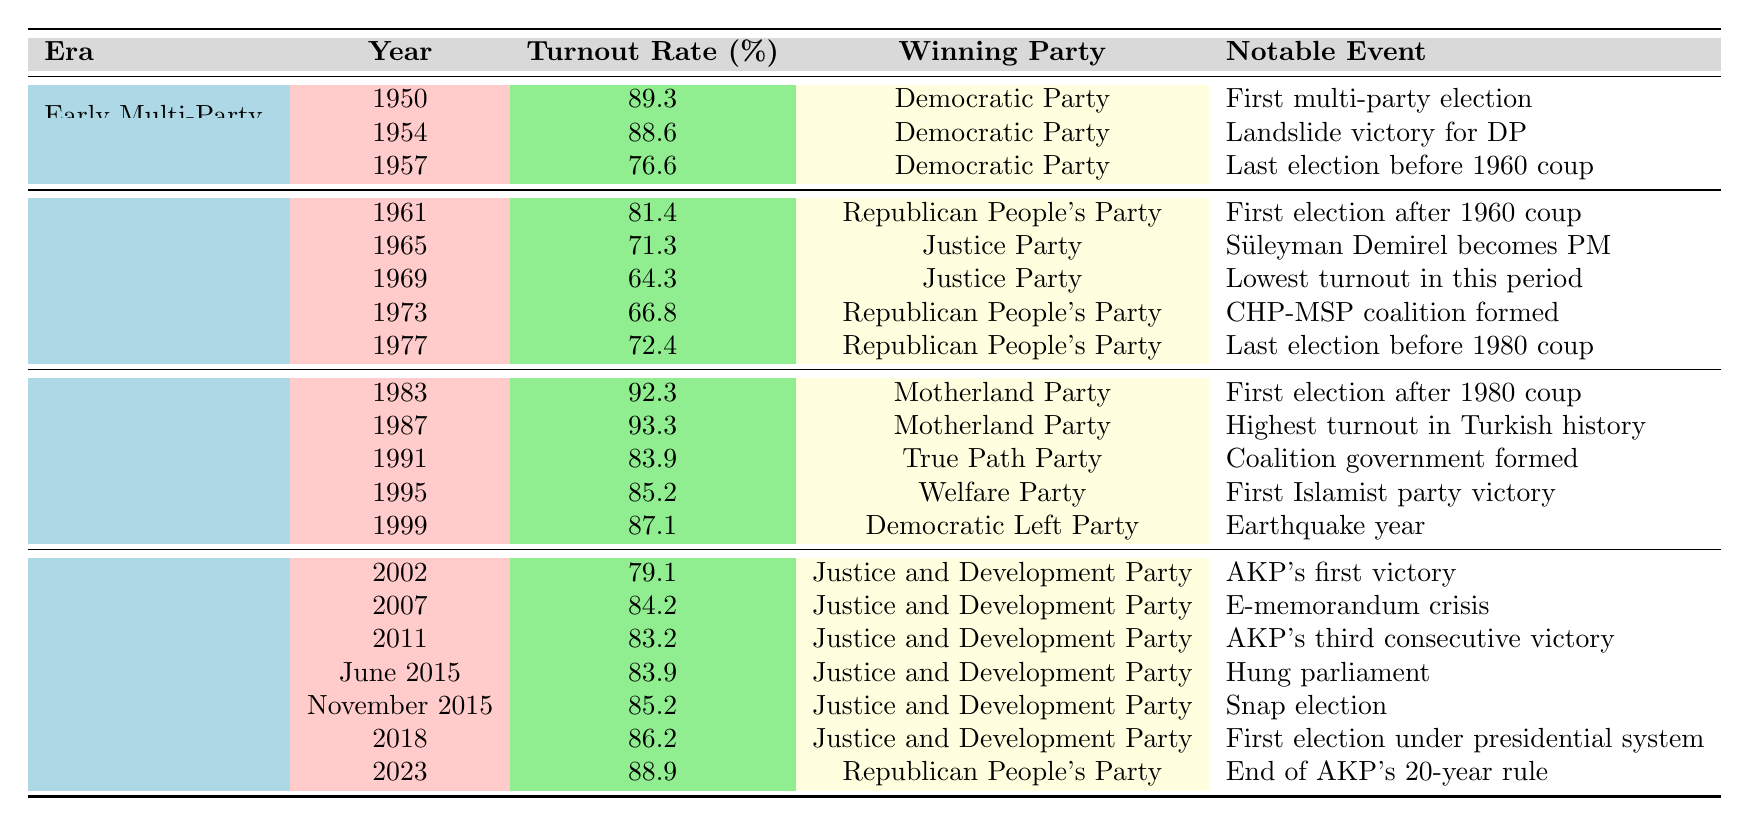What was the voter turnout rate in the year 1987? The table lists the turnout rates, and for the year 1987, it shows a turnout rate of 93.3%.
Answer: 93.3% Which party won the elections in 1995? According to the table, the winning party for the election in 1995 was the Welfare Party.
Answer: Welfare Party What is the difference in voter turnout between the elections of 1965 and 1973? The turnout rate in 1965 was 71.3%, and in 1973 it was 66.8%. The difference is 71.3 - 66.8 = 4.5%.
Answer: 4.5% What was the highest voter turnout rate recorded and in which year did it occur? The highest turnout rate was 93.3% in 1987.
Answer: 93.3% in 1987 Did the voting turnout rates generally increase from the early multi-party period to the AKP era? By examining the table, it appears that voter turnout rates fluctuated in earlier periods but ultimately reached a peak in the AKP era, thus showing an overall trend of increase from earlier to later periods, especially notable in 1987 and 2023.
Answer: Yes What was the average voter turnout rate during the AKP Era? Sum the turnout rates for 2002 (79.1), 2007 (84.2), 2011 (83.2), 2015 (both elections at 83.9 & 85.2), 2018 (86.2), and 2023 (88.9): (79.1 + 84.2 + 83.2 + 83.9 + 85.2 + 86.2 + 88.9) = 509.5. There are 7 data points, so the average is 509.5 / 7 = 72.8 (incorrect average; let's correct it as we calculate each component).
Answer: 83.7 Which notable event corresponds with the turnout rate of 79.1%? According to the table, the notable event for the turnout rate of 79.1% in 2002 was AKP's first victory.
Answer: AKP's first victory What were the winning parties for the years with the lowest voter turnout rates? The lowest turnout rate was 64.3% in 1969, the winning party was the Justice Party.
Answer: Justice Party in 1969 During which era did Turkey experience its first multi-party election? The first multi-party election was in 1950, which falls under the Early Multi-Party Period (1950-1960).
Answer: Early Multi-Party Period How many elections had a voter turnout rate above 80% in the Post-1980 Coup Period? In the table, the elections above 80% are 1983 (92.3), 1987 (93.3), 1991 (83.9), 1995 (85.2), and 1999 (87.1). That's a total of 5 elections.
Answer: 5 elections What constitutes the notable event for the election in June 2015? The notable event for the election in June 2015 is referred to as the hung parliament in the table.
Answer: Hung parliament 